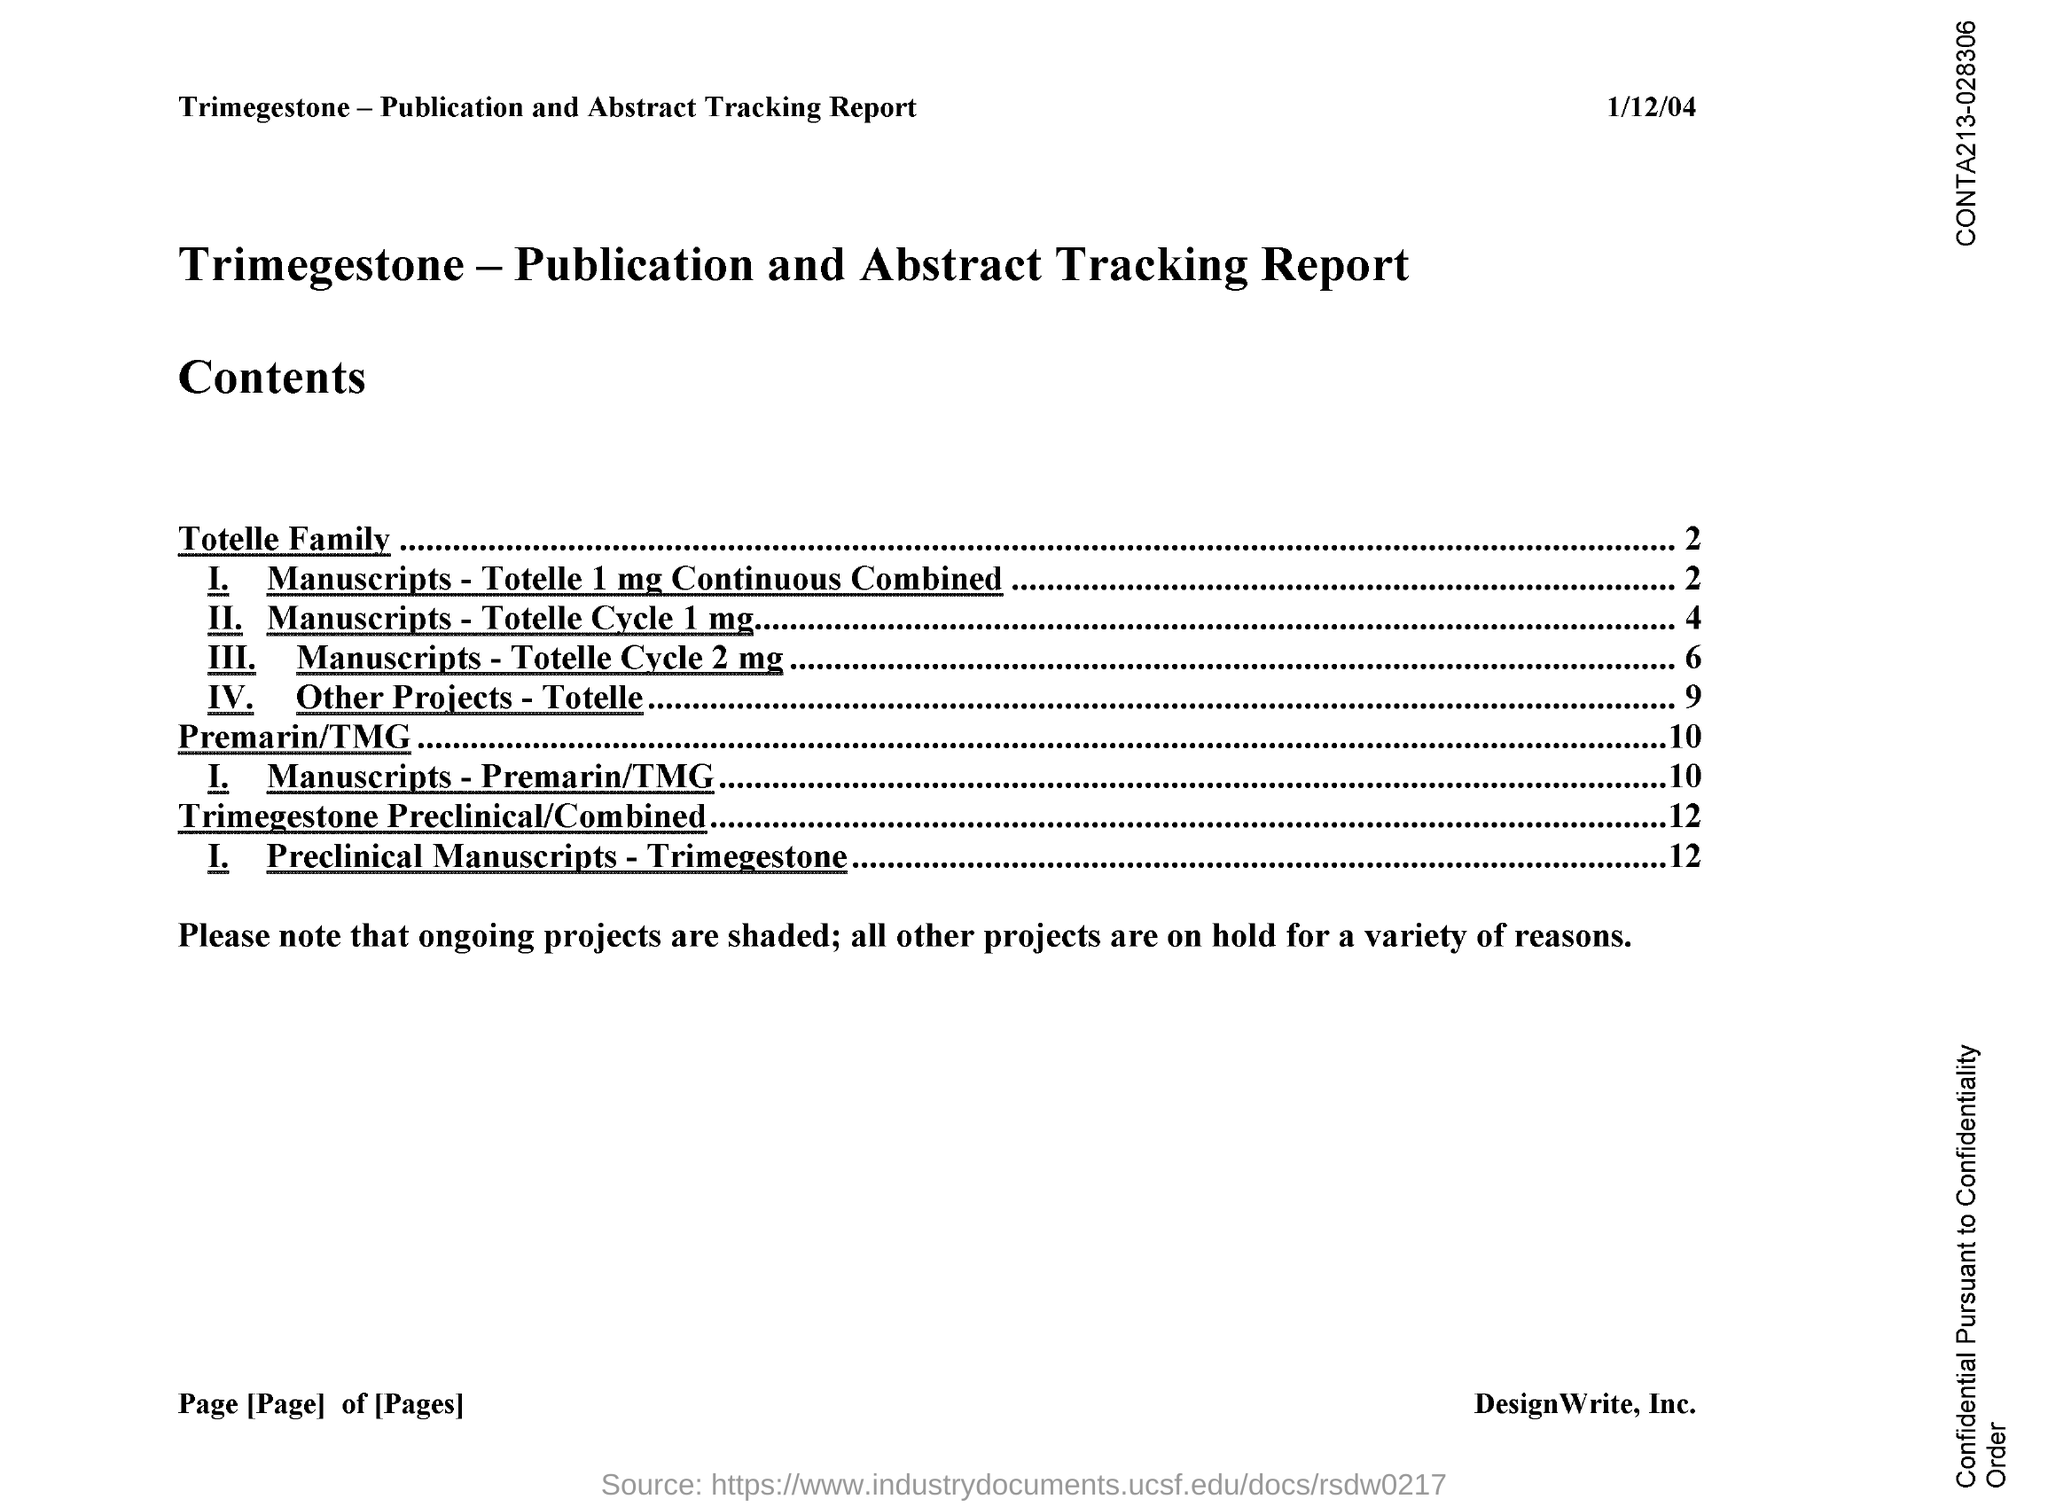Indicate a few pertinent items in this graphic. All projects are currently on hold due to a variety of reasons. The document indicates that the date is January 12, 2004. 